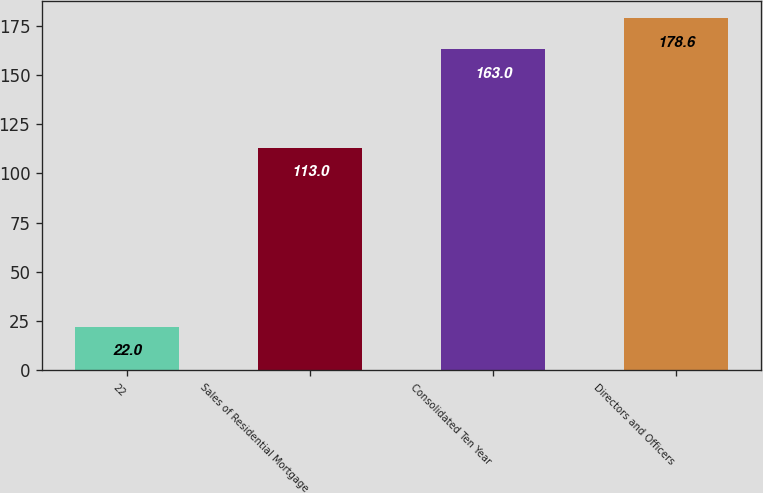Convert chart to OTSL. <chart><loc_0><loc_0><loc_500><loc_500><bar_chart><fcel>22<fcel>Sales of Residential Mortgage<fcel>Consolidated Ten Year<fcel>Directors and Officers<nl><fcel>22<fcel>113<fcel>163<fcel>178.6<nl></chart> 